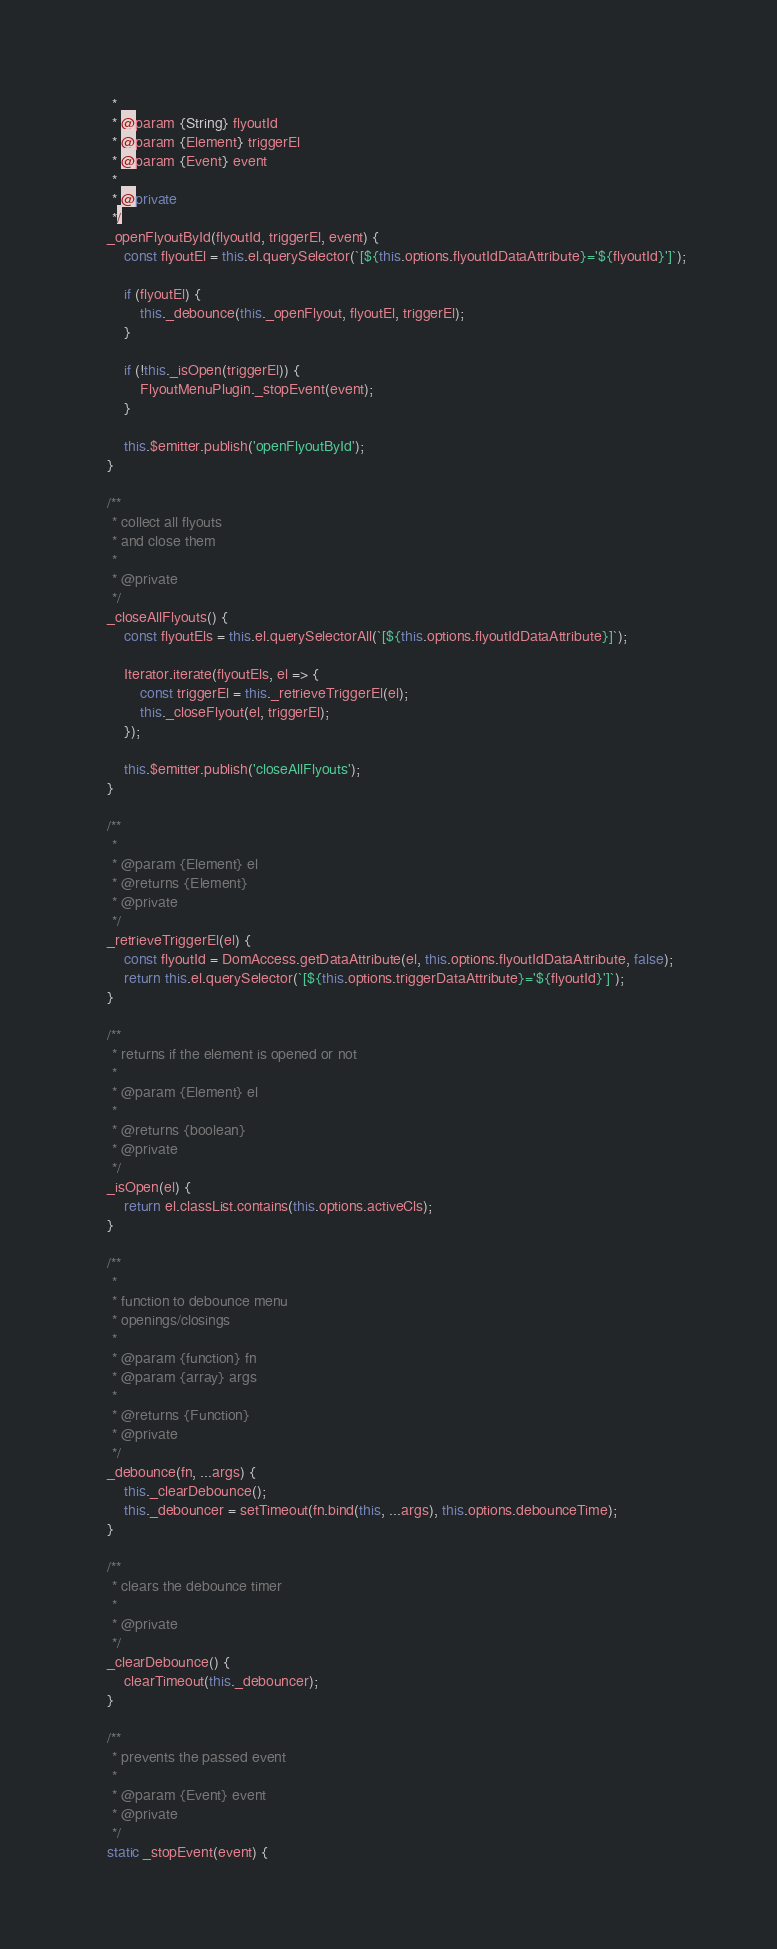Convert code to text. <code><loc_0><loc_0><loc_500><loc_500><_JavaScript_>     *
     * @param {String} flyoutId
     * @param {Element} triggerEl
     * @param {Event} event
     *
     * @private
     */
    _openFlyoutById(flyoutId, triggerEl, event) {
        const flyoutEl = this.el.querySelector(`[${this.options.flyoutIdDataAttribute}='${flyoutId}']`);

        if (flyoutEl) {
            this._debounce(this._openFlyout, flyoutEl, triggerEl);
        }

        if (!this._isOpen(triggerEl)) {
            FlyoutMenuPlugin._stopEvent(event);
        }

        this.$emitter.publish('openFlyoutById');
    }

    /**
     * collect all flyouts
     * and close them
     *
     * @private
     */
    _closeAllFlyouts() {
        const flyoutEls = this.el.querySelectorAll(`[${this.options.flyoutIdDataAttribute}]`);

        Iterator.iterate(flyoutEls, el => {
            const triggerEl = this._retrieveTriggerEl(el);
            this._closeFlyout(el, triggerEl);
        });

        this.$emitter.publish('closeAllFlyouts');
    }

    /**
     *
     * @param {Element} el
     * @returns {Element}
     * @private
     */
    _retrieveTriggerEl(el) {
        const flyoutId = DomAccess.getDataAttribute(el, this.options.flyoutIdDataAttribute, false);
        return this.el.querySelector(`[${this.options.triggerDataAttribute}='${flyoutId}']`);
    }

    /**
     * returns if the element is opened or not
     *
     * @param {Element} el
     *
     * @returns {boolean}
     * @private
     */
    _isOpen(el) {
        return el.classList.contains(this.options.activeCls);
    }

    /**
     *
     * function to debounce menu
     * openings/closings
     *
     * @param {function} fn
     * @param {array} args
     *
     * @returns {Function}
     * @private
     */
    _debounce(fn, ...args) {
        this._clearDebounce();
        this._debouncer = setTimeout(fn.bind(this, ...args), this.options.debounceTime);
    }

    /**
     * clears the debounce timer
     *
     * @private
     */
    _clearDebounce() {
        clearTimeout(this._debouncer);
    }

    /**
     * prevents the passed event
     *
     * @param {Event} event
     * @private
     */
    static _stopEvent(event) {</code> 